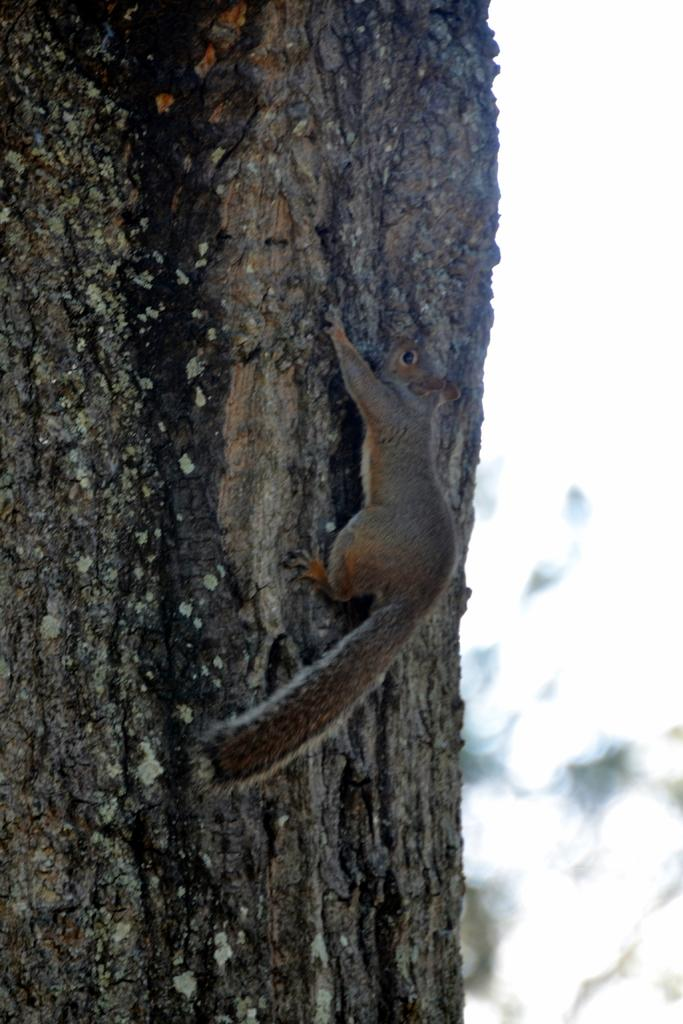What type of animal is in the image? There is a squirrel in the image. Where is the squirrel located? The squirrel is on a tree trunk. Can you describe the background of the image? The background of the image is blurry. What type of cloud can be seen in the image? There is no cloud present in the image; it features a squirrel on a tree trunk with a blurry background. 